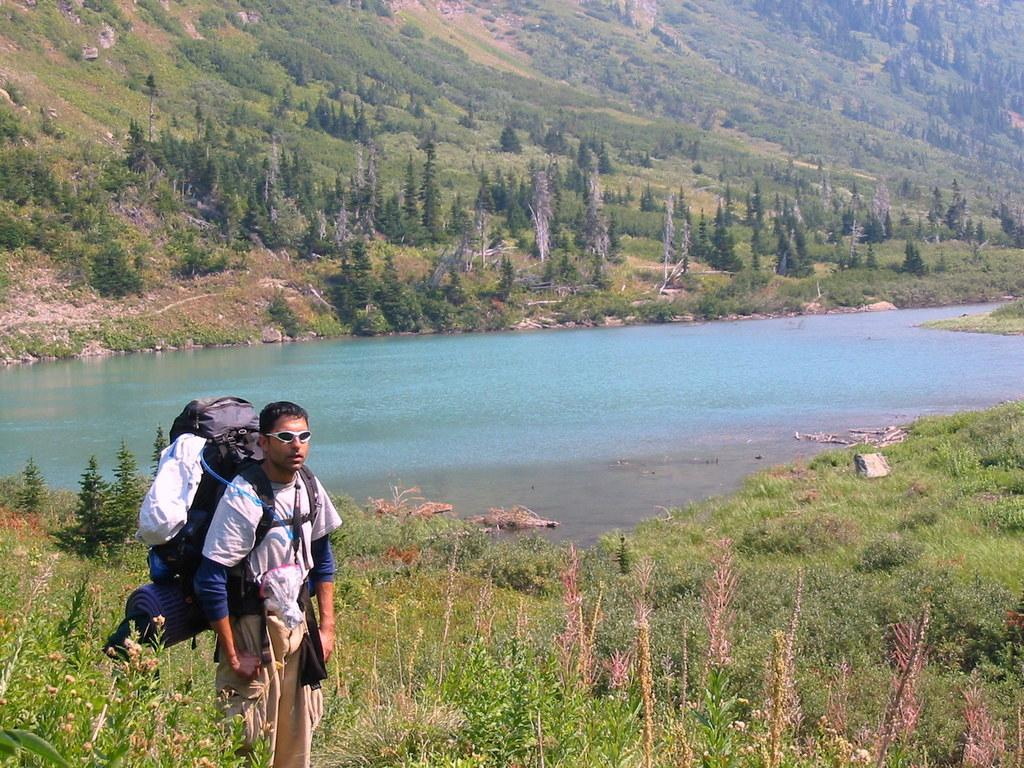Where was the image taken? The image was taken outdoors. Can you describe the man on the left side of the image? The man is standing on the left side of the image, and he is wearing a backpack. What can be seen in the background of the image? In the background of the image, there is a river, trees, and a hill. What type of key is the farmer using to unlock the connection in the image? There is no farmer, key, or connection present in the image. 